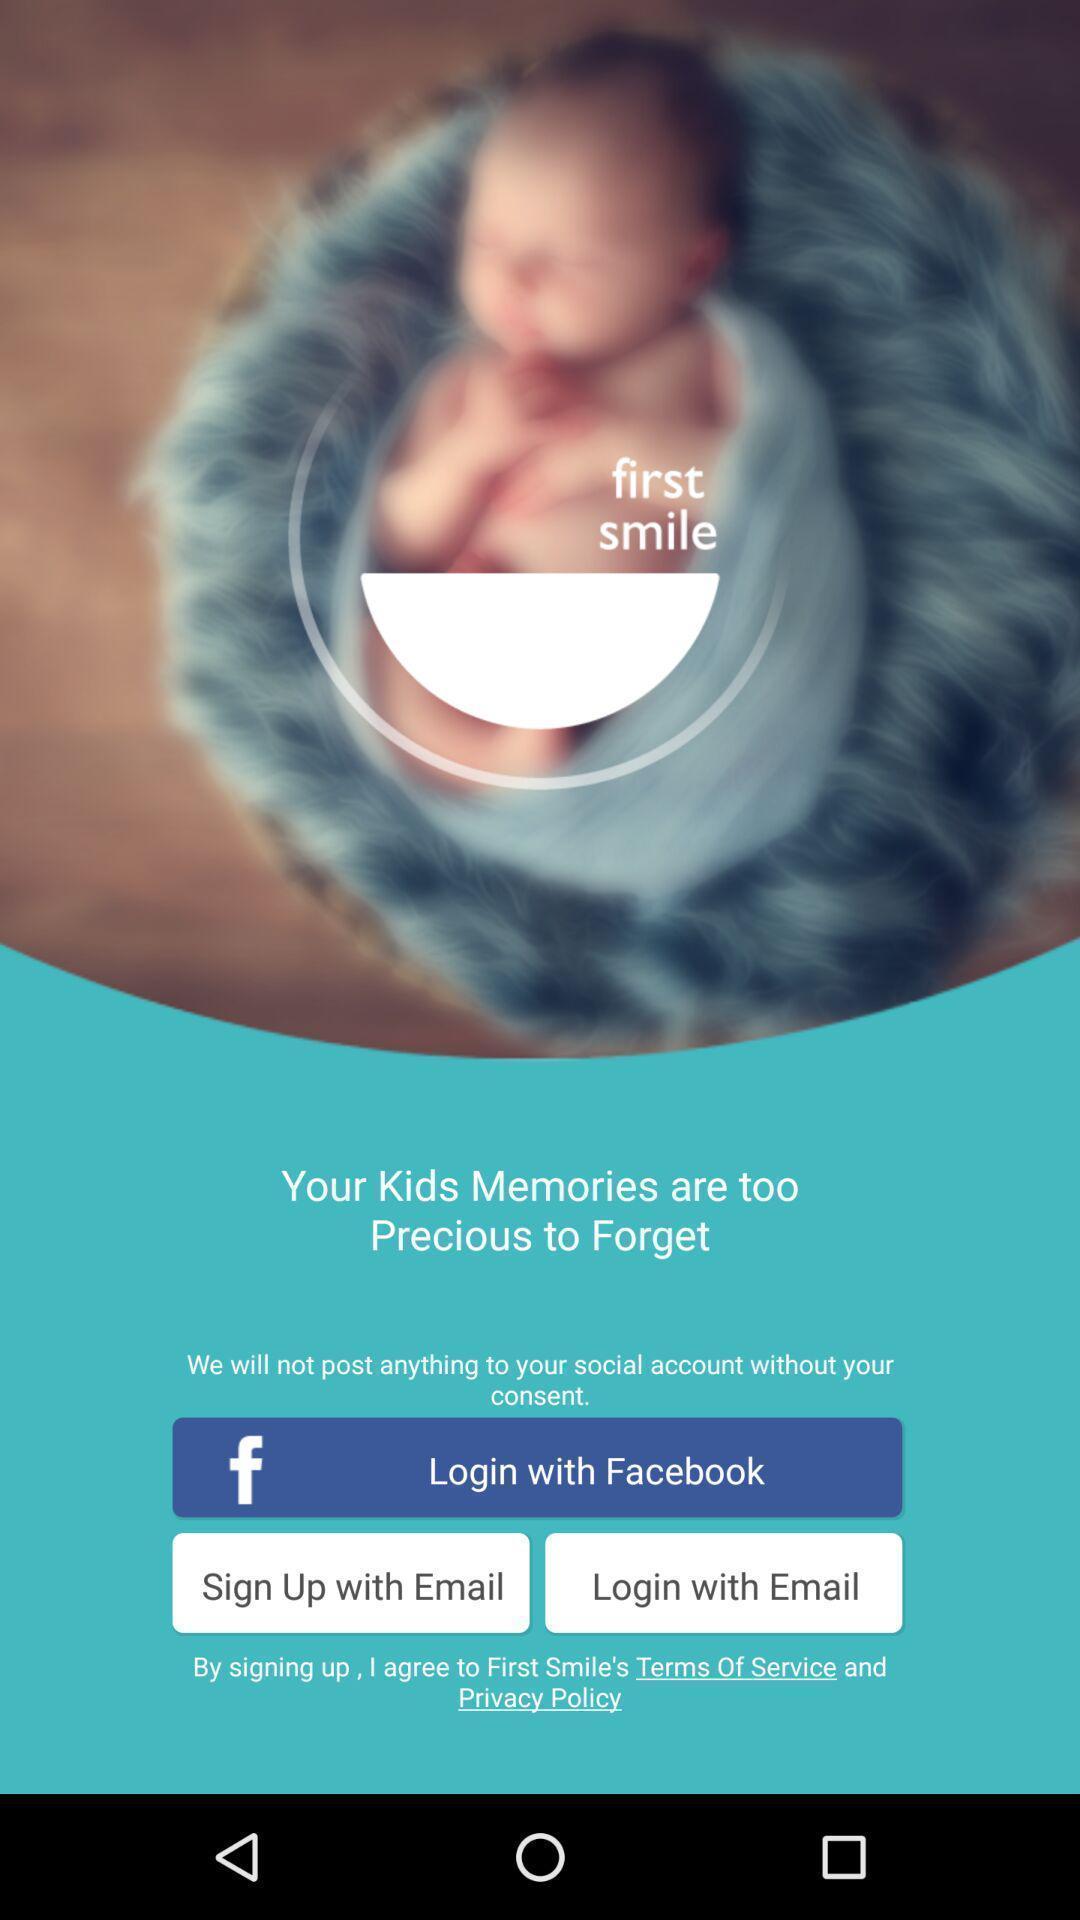Describe this image in words. Welcome page displaying to login in an application. 